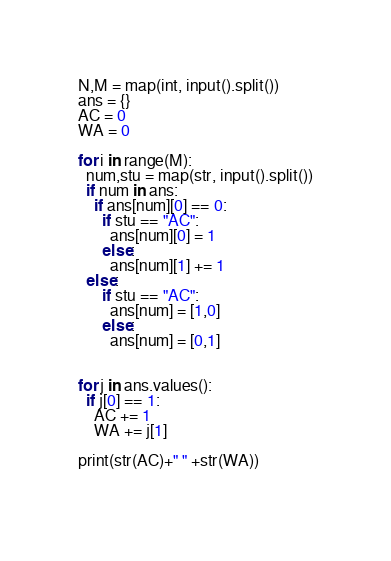<code> <loc_0><loc_0><loc_500><loc_500><_Python_>N,M = map(int, input().split())
ans = {}
AC = 0
WA = 0

for i in range(M):
  num,stu = map(str, input().split())
  if num in ans:
    if ans[num][0] == 0:
      if stu == "AC":
        ans[num][0] = 1
      else:
        ans[num][1] += 1
  else:
      if stu == "AC":
        ans[num] = [1,0]
      else:
        ans[num] = [0,1]

  
for j in ans.values():
  if j[0] == 1:
    AC += 1
    WA += j[1]
    
print(str(AC)+" " +str(WA))
        </code> 